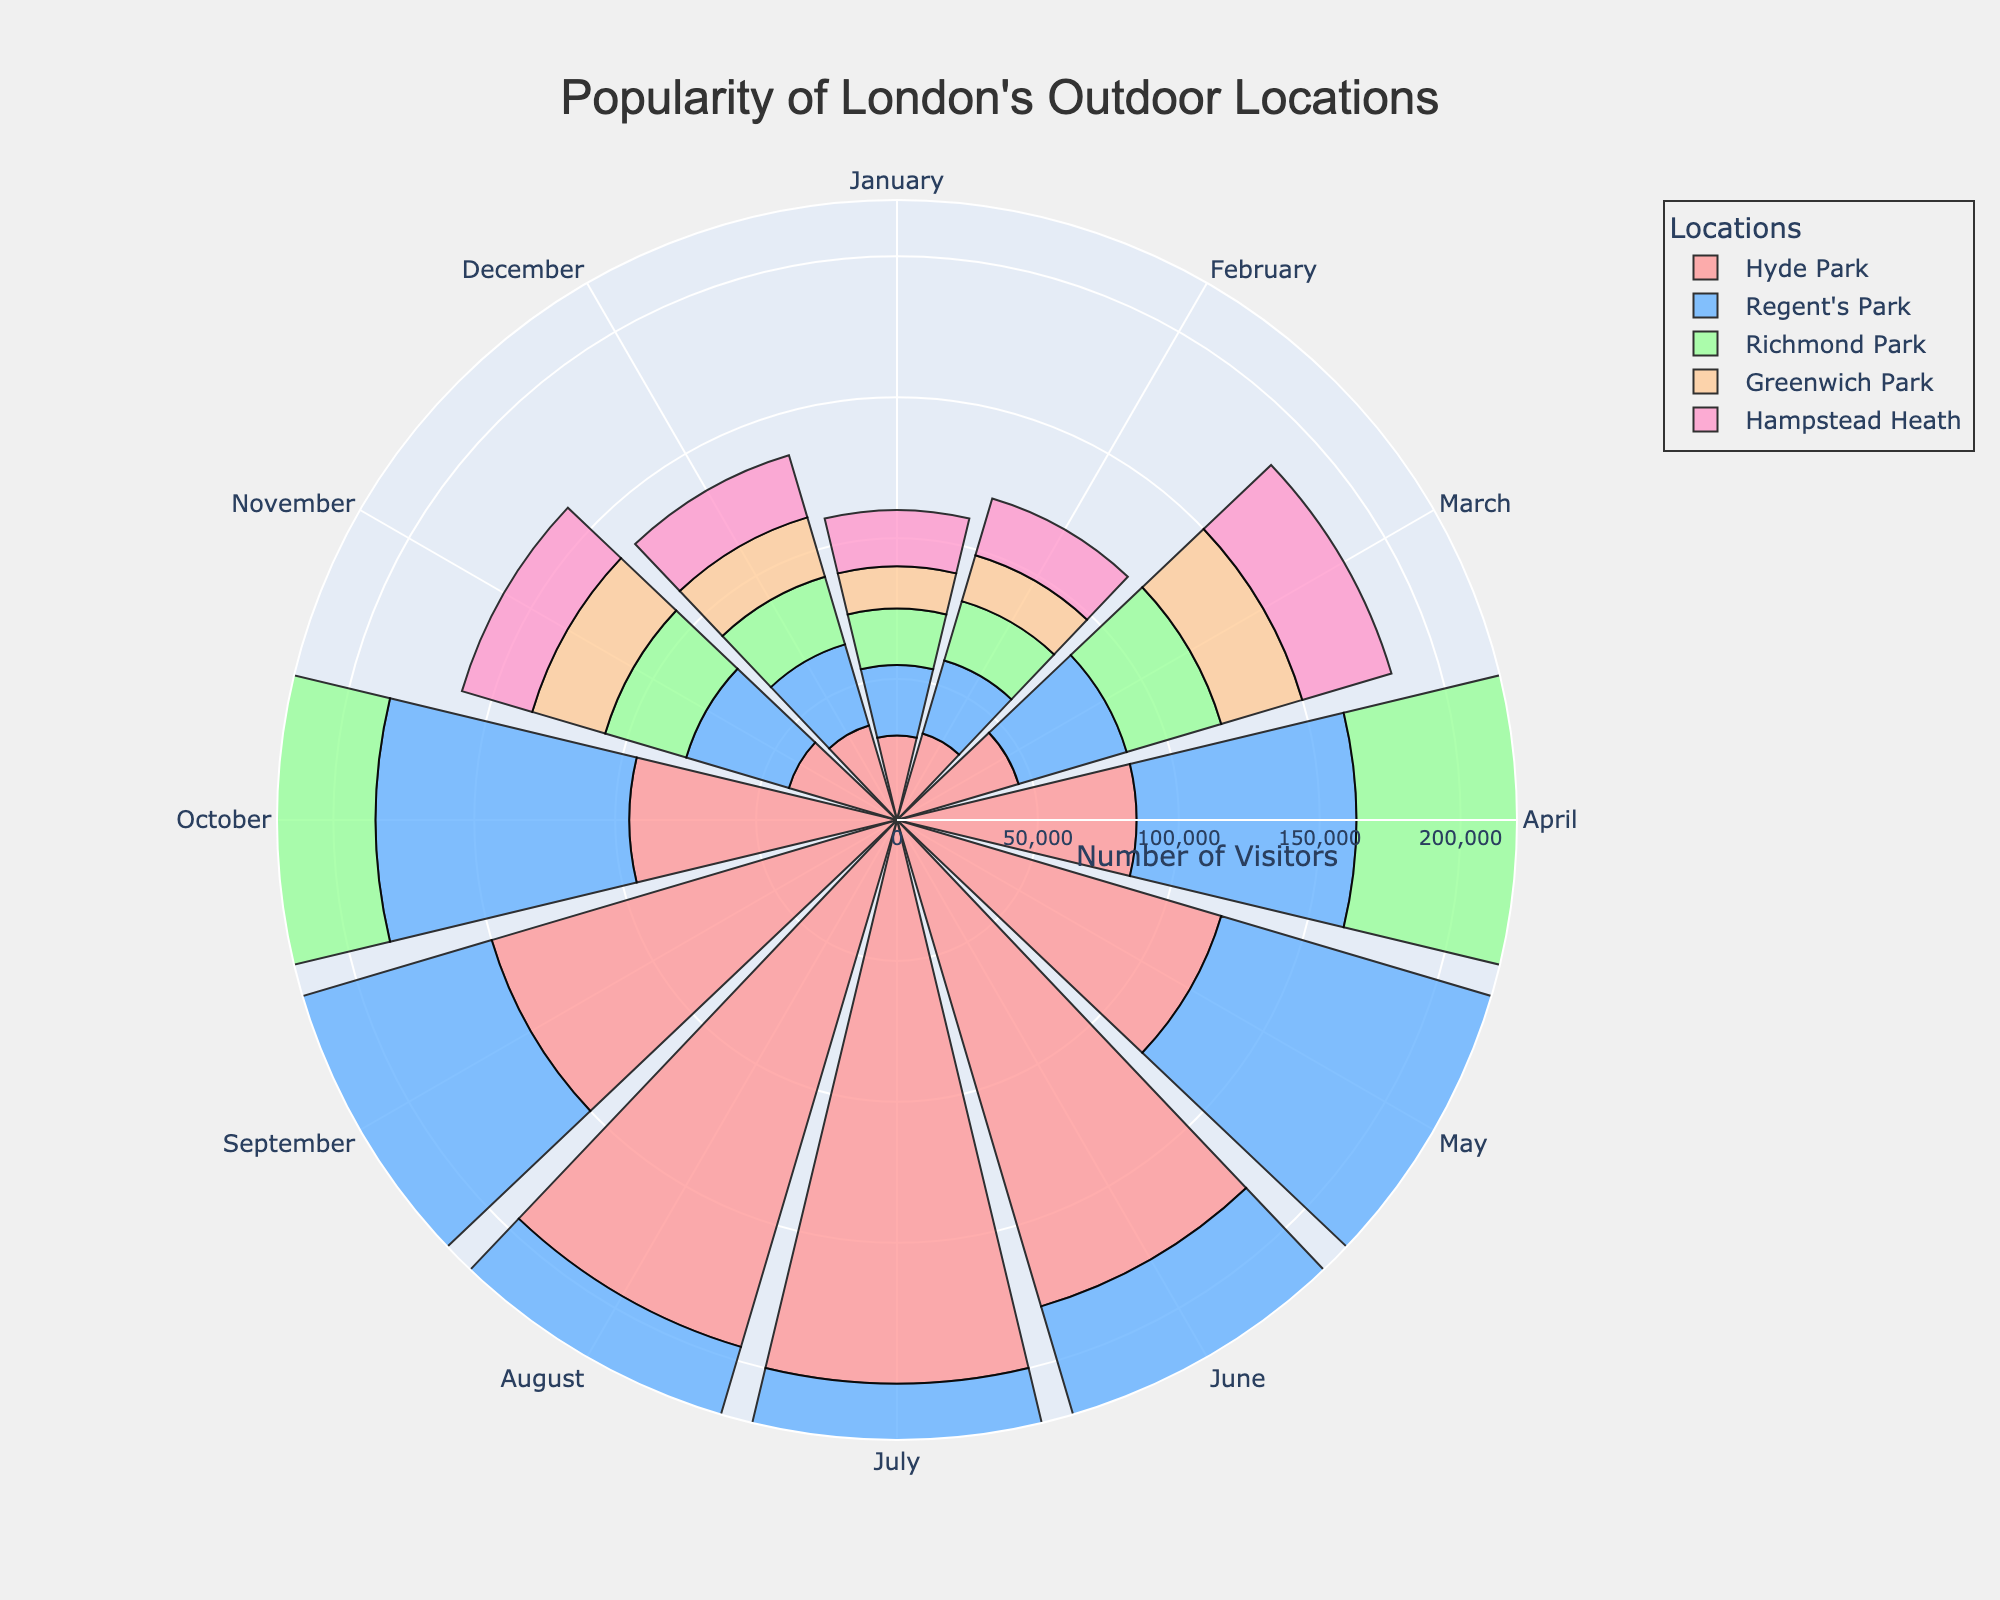Which park has the highest number of visitors in July? To find the park with the highest number of visitors in July, look at the data points for each park in July on the figure. Hyde Park has 200,000 visitors, Regent's Park has 175,000, Richmond Park has 160,000, Greenwich Park has 150,000, and Hampstead Heath has 145,000. Hence, Hyde Park has the highest number of visitors in July.
Answer: Hyde Park In which months does Greenwich Park have fewer than 50,000 visitors? Locate the data points for Greenwich Park for each month and identify those with a number of visitors under 50,000. The months with fewer than 50,000 visitors are January (15,000), February (17,000), March (30,000), November (27,000), and December (22,000).
Answer: January, February, March, November, December What is the combined number of visitors for Richmond Park in June and July? To find the combined number of visitors for Richmond Park in June and July, sum the visitors for these months. June has 150,000 visitors and July has 160,000 visitors. Combined, this is 150,000 + 160,000 = 310,000.
Answer: 310,000 Which location has the least variation in visitor numbers throughout the year? To find the location with the least variation in visitor numbers, look at the polar bars for each location and see which are more evenly distributed. Greenwich Park and Hampstead Heath appear less varied throughout the year as the bars show less dramatic differences in height across months.
Answer: Greenwich Park, Hampstead Heath In which month does Hyde Park have the second-highest number of visitors? Look at the data points for Hyde Park and identify the month with the second-highest number of visitors. July has the highest (200,000), and June has the second-highest (180,000).
Answer: June Which park has the greatest drop in visitors from August to September? Compare the number of visitors in August and September for each park and calculate the drop. Hyde Park drops from 195,000 to 150,000 (45,000 drop), Regent's Park from 170,000 to 140,000 (30,000 drop), Richmond Park from 158,000 to 130,000 (28,000 drop), Greenwich Park from 145,000 to 120,000 (25,000 drop), Hampstead Heath from 142,000 to 115,000 (27,000 drop). The largest drop is in Hyde Park at 45,000.
Answer: Hyde Park For which months does Hampstead Heath have fewer than 30,000 visitors? Identify the months for Hampstead Heath where the number of visitors is less than 30,000. January (20,000), February (21,000), November (26,000), and December (23,000) have fewer than 30,000 visitors.
Answer: January, February, November, December By how much do the visitors in June surpass those in May for Regent's Park? Check the number of visitors in May (115,000) and June (160,000) for Regent's Park and find the difference: 160,000 - 115,000 = 45,000.
Answer: 45,000 Which park has the highest number of visitors in October? Compare visitor numbers for October across all parks. Hyde Park has 95,000, Regent's Park 90,000, Richmond Park 80,000, Greenwich Park 75,000, and Hampstead Heath 72,000. The highest number of visitors in October is in Hyde Park.
Answer: Hyde Park 